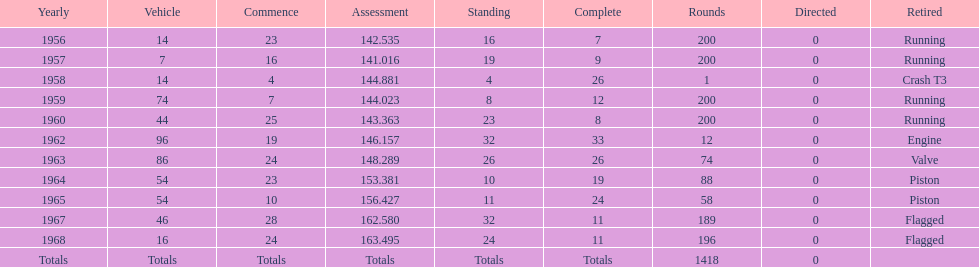Did bob veith drive more indy 500 laps in the 1950s or 1960s? 1960s. 